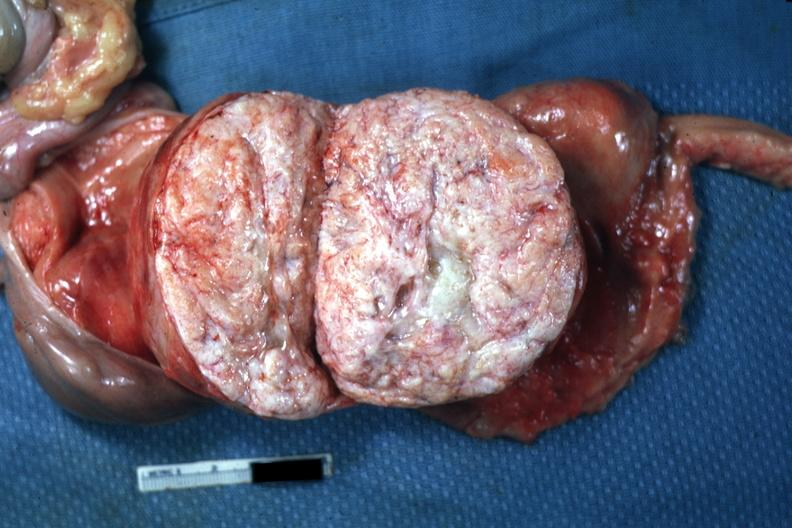what is present?
Answer the question using a single word or phrase. Leiomyoma 